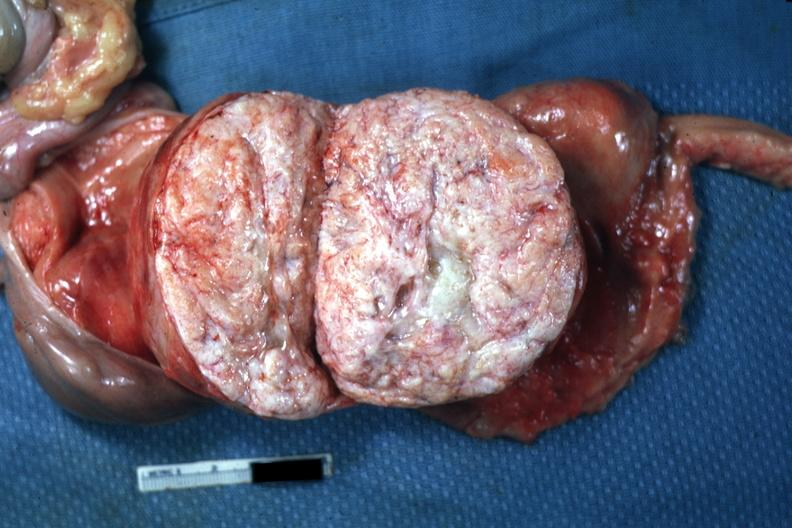what is present?
Answer the question using a single word or phrase. Leiomyoma 